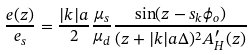Convert formula to latex. <formula><loc_0><loc_0><loc_500><loc_500>\frac { e ( z ) } { e _ { s } } = \frac { | k | a } { 2 } \frac { \mu _ { s } } { \mu _ { d } } \frac { \sin ( z - s _ { k } \phi _ { o } ) } { ( z + | k | a \Delta ) ^ { 2 } A ^ { \prime } _ { H } ( z ) }</formula> 